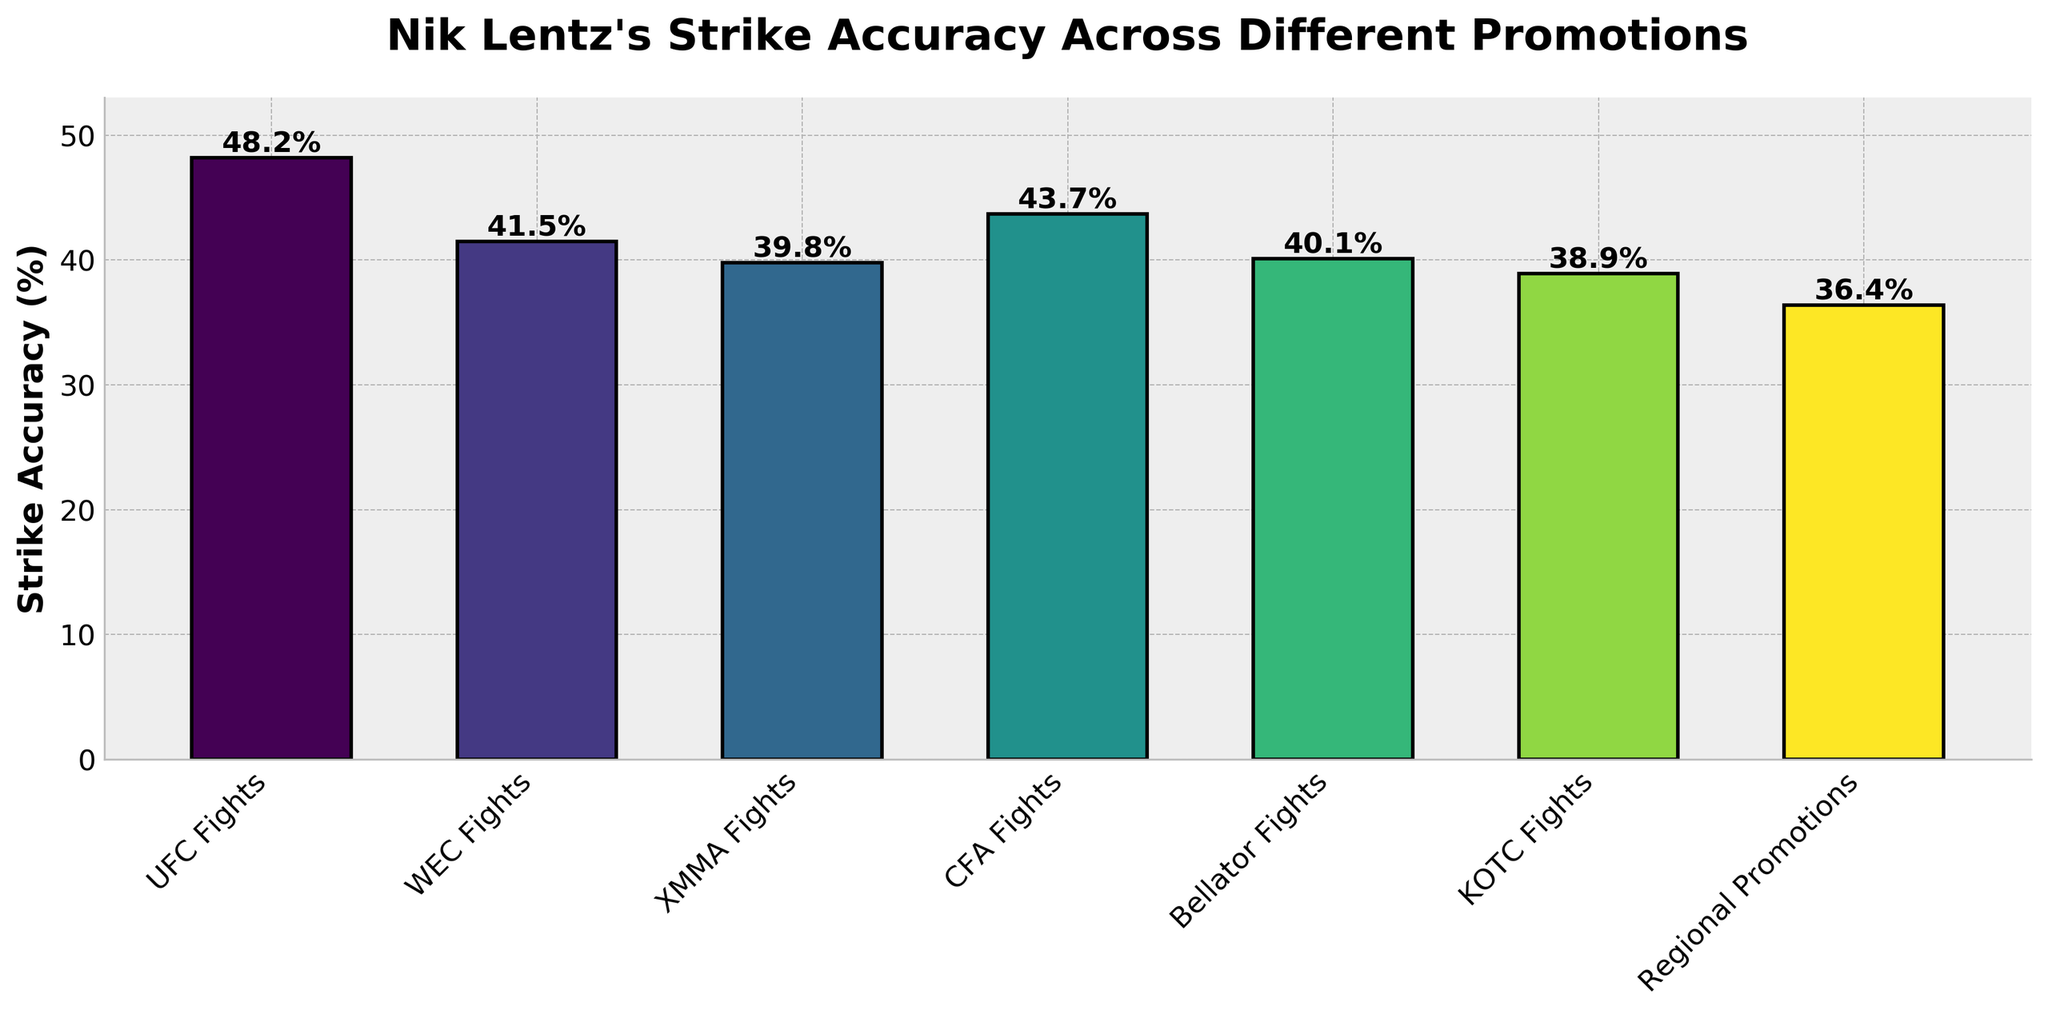What's the strike accuracy rate for Nik Lentz in UFC fights? The bar chart shows the strike accuracy rates for different fight types. Look for the bar labeled "UFC Fights" and read its height, which represents the strike accuracy rate.
Answer: 48.2% How does Nik Lentz's strike accuracy in UFC fights compare to WEC fights? The chart shows the strike accuracy rates for UFC fights and WEC fights. Check the height of both bars labeled "UFC Fights" and "WEC Fights" to compare them. UFC fights have an accuracy of 48.2% and WEC fights have 41.5%.
Answer: Higher in UFC fights Which promotion has the lowest strike accuracy for Nik Lentz? Identify the shortest bar in the chart, which represents the lowest strike accuracy rate.
Answer: Regional Promotions How much higher is Nik Lentz's strike accuracy in UFC fights compared to the average strike accuracy across all other promotions? First, calculate the average strike accuracy of all non-UFC promotions: (41.5 + 39.8 + 43.7 + 40.1 + 38.9 + 36.4) / 6 = 40.067%. Then, subtract this average from the UFC strike accuracy (48.2% - 40.067%).
Answer: 8.133% Which promotions have a strike accuracy rate lower than 40% for Nik Lentz? Examine the bars and their heights to identify those with strike accuracy rates below 40%.
Answer: XMMA Fights, KOTC Fights, Regional Promotions What is the difference in strike accuracy between the highest and lowest rates for Nik Lentz? Identify the maximum and minimum strike accuracy rates from the chart: UFC fights (48.2%) and Regional Promotions (36.4%), then subtract the minimum from the maximum (48.2% - 36.4%).
Answer: 11.8% Is Nik Lentz's strike accuracy in KOTC fights higher or lower than in CFA fights, and by how much? Check the bar heights for "KOTC Fights" and "CFA Fights". KOTC is 38.9% and CFA is 43.7%. Subtract KOTC's rate from CFA's rate (43.7% - 38.9%).
Answer: Lower by 4.8% What's the total strike accuracy rate if you combine all the promotion rates displayed? Sum up all the strike accuracy rates from the bars: 48.2 + 41.5 + 39.8 + 43.7 + 40.1 + 38.9 + 36.4 = 288.6.
Answer: 288.6% If we arrange the promotions in descending order of strike accuracy, which promotion is third on the list? Sort the strike accuracies from highest to lowest: (48.2, 43.7, 41.5, 40.1, 39.8, 38.9, 36.4). Identify the third value and its corresponding promotion.
Answer: WEC Fights How many promotions have strike accuracy rates between 39% and 44%? Look for bars whose heights fall within the 39-44% range: XMMA (39.8%), CFA (43.7%), Bellator (40.1%), KOTC (38.9%). Out of these, only CFA, Bellator, and XMMA are within range.
Answer: 3 